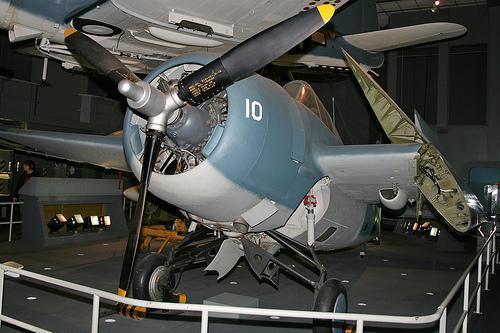How many propellers are on the front of the plane?
Give a very brief answer. 3. How many wheels does the plane have?
Give a very brief answer. 2. How many planes are shown?
Give a very brief answer. 1. How many blades are on the propeller?
Give a very brief answer. 3. How many wheels are on the plane?
Give a very brief answer. 2. How many wheels are there?
Give a very brief answer. 2. 